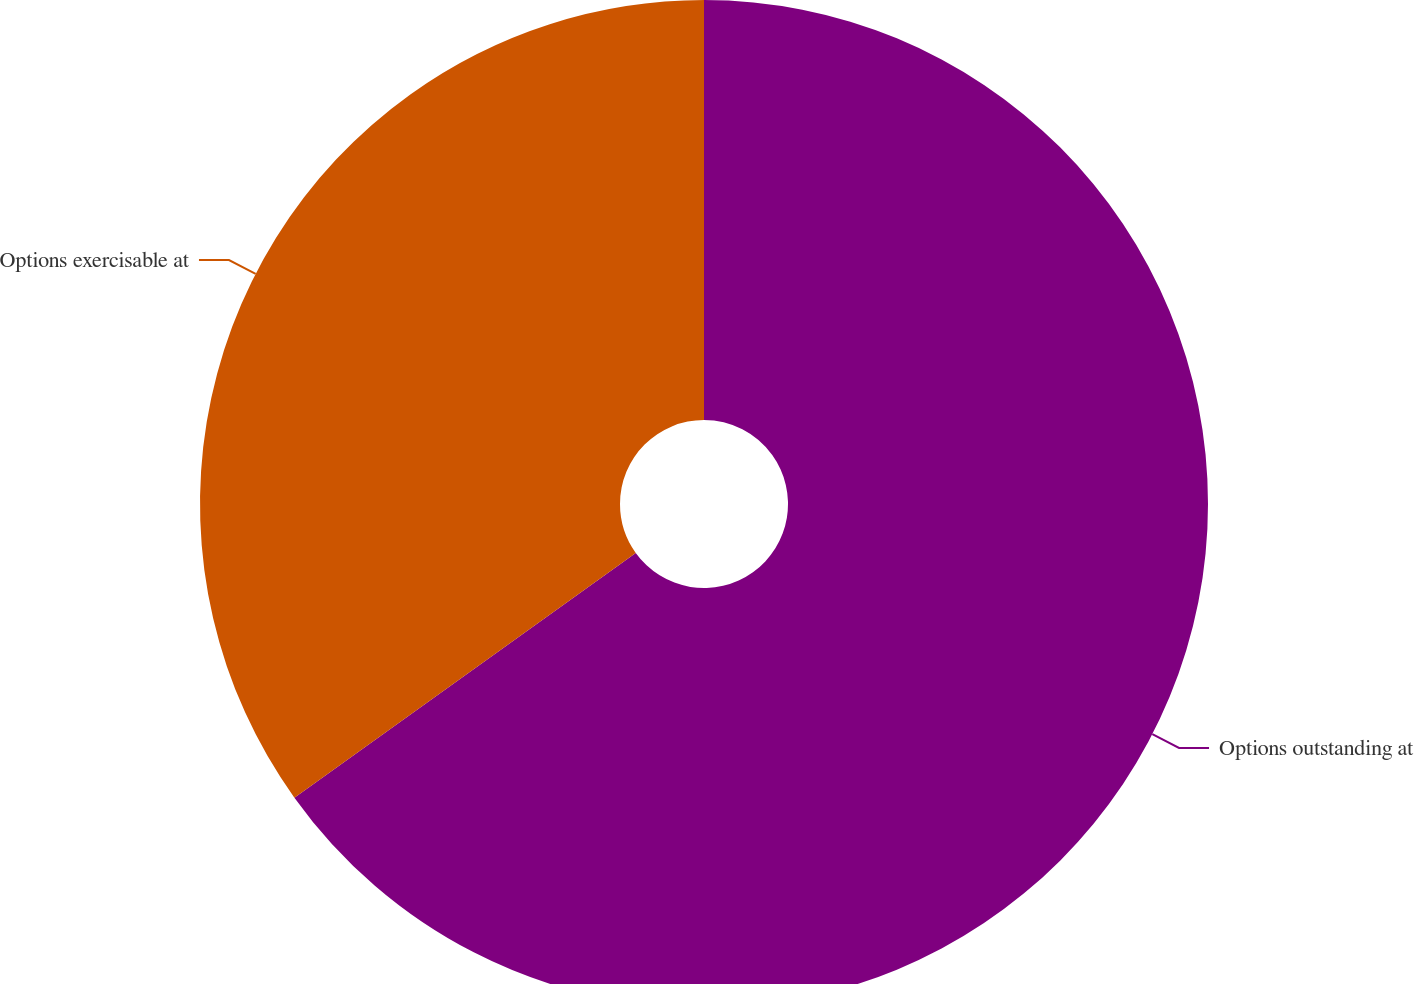<chart> <loc_0><loc_0><loc_500><loc_500><pie_chart><fcel>Options outstanding at<fcel>Options exercisable at<nl><fcel>65.1%<fcel>34.9%<nl></chart> 